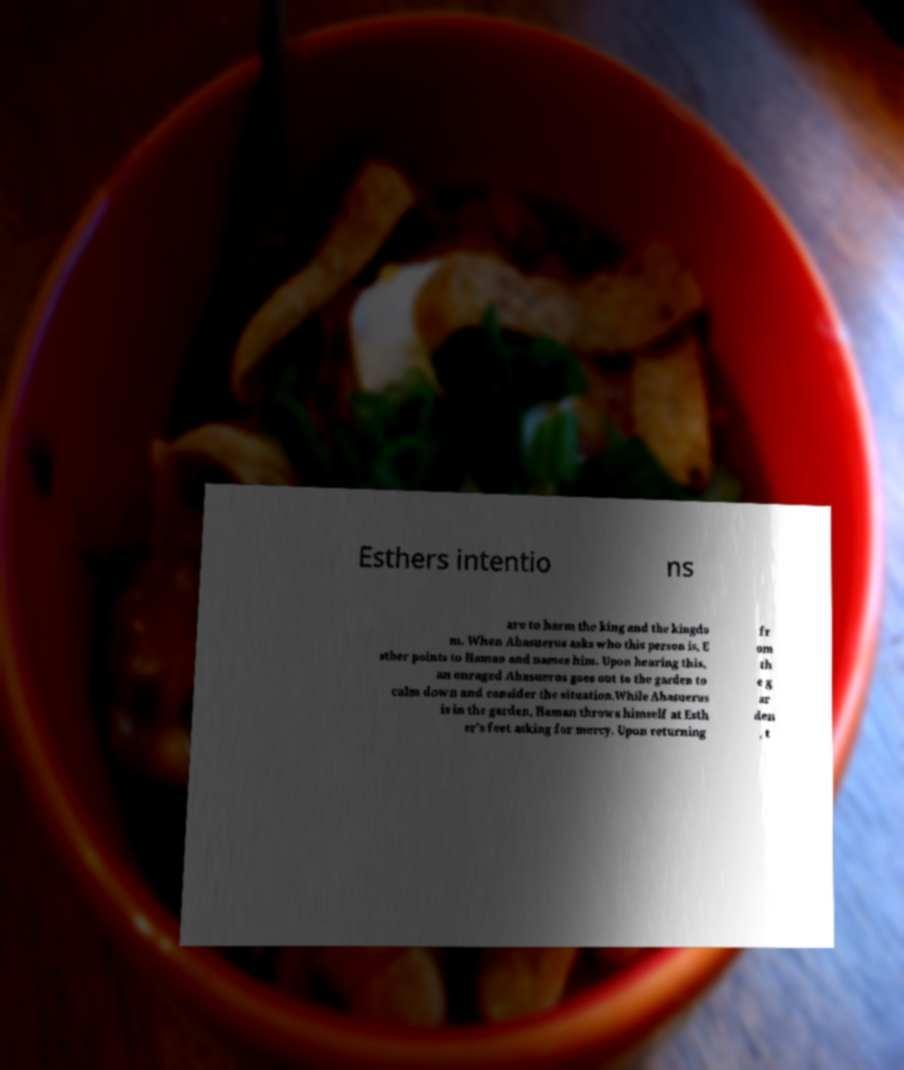Please read and relay the text visible in this image. What does it say? Esthers intentio ns are to harm the king and the kingdo m. When Ahasuerus asks who this person is, E sther points to Haman and names him. Upon hearing this, an enraged Ahasuerus goes out to the garden to calm down and consider the situation.While Ahasuerus is in the garden, Haman throws himself at Esth er's feet asking for mercy. Upon returning fr om th e g ar den , t 